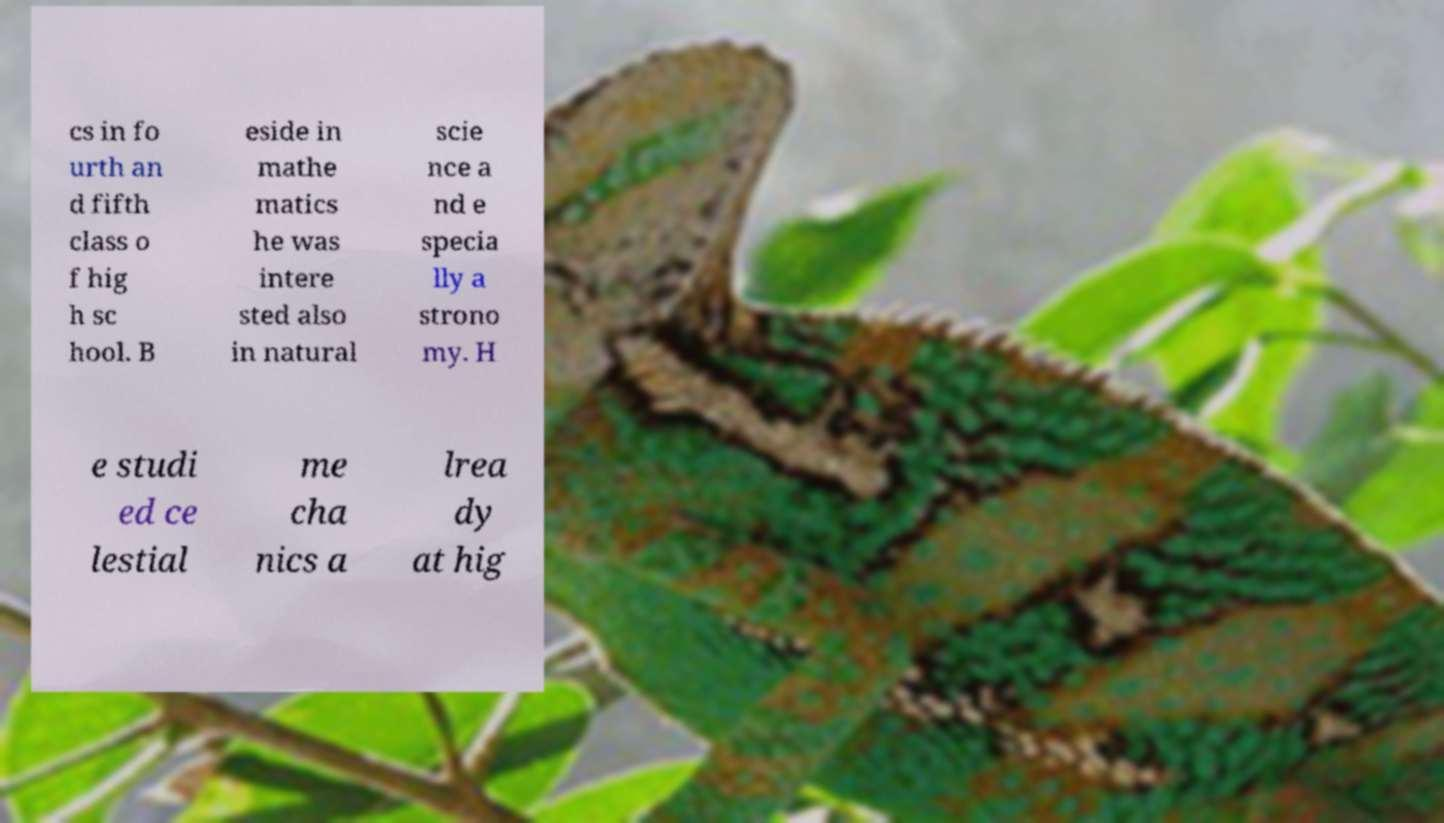I need the written content from this picture converted into text. Can you do that? cs in fo urth an d fifth class o f hig h sc hool. B eside in mathe matics he was intere sted also in natural scie nce a nd e specia lly a strono my. H e studi ed ce lestial me cha nics a lrea dy at hig 